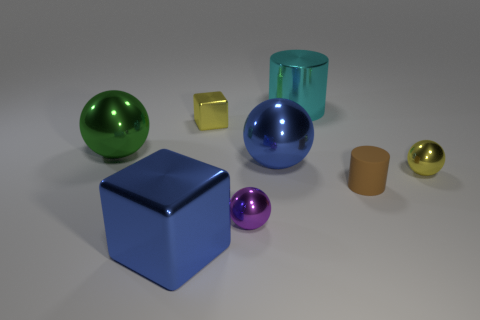What number of red things are either tiny objects or small metallic objects?
Offer a very short reply. 0. There is a yellow object that is the same size as the yellow cube; what is its shape?
Provide a succinct answer. Sphere. How many other objects are there of the same color as the large metal cylinder?
Your answer should be very brief. 0. There is a metal ball to the left of the tiny sphere on the left side of the yellow sphere; how big is it?
Keep it short and to the point. Large. Do the cylinder right of the cyan metal object and the large cyan cylinder have the same material?
Give a very brief answer. No. What shape is the big blue shiny thing left of the small yellow metallic cube?
Ensure brevity in your answer.  Cube. What number of metal spheres are the same size as the yellow cube?
Make the answer very short. 2. The blue metal cube is what size?
Your response must be concise. Large. There is a brown rubber thing; how many large things are in front of it?
Offer a terse response. 1. There is a tiny purple thing that is the same material as the green ball; what is its shape?
Your response must be concise. Sphere. 